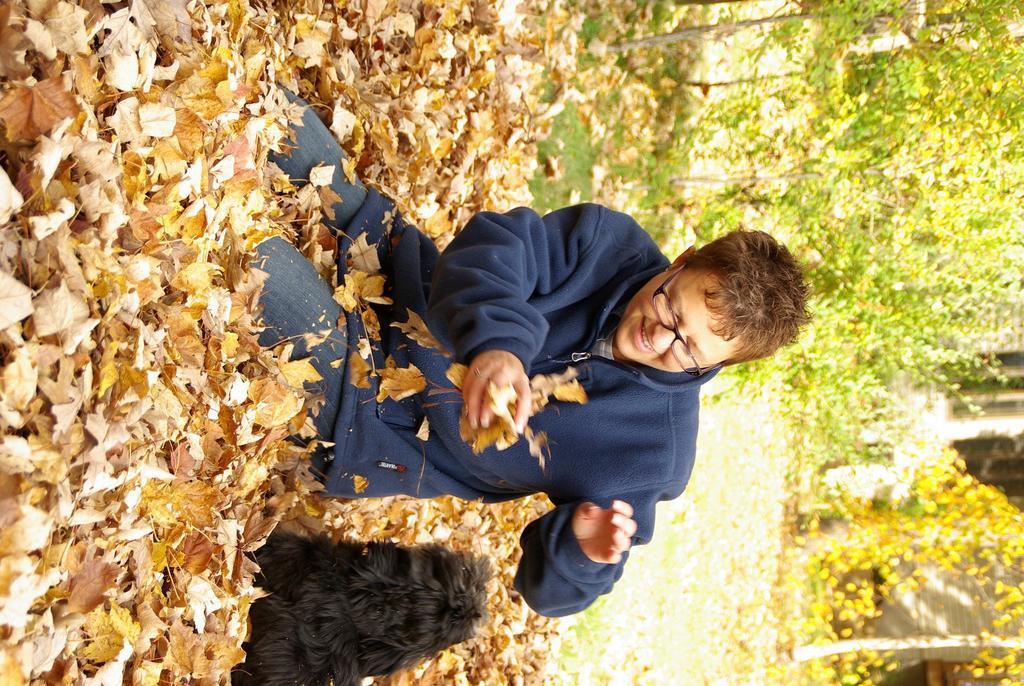Describe this image in one or two sentences. In the foreground of this image, there is a person and an animal on the dry leaves. In the background, there are trees and it seems like the wall and the windows of a building. 